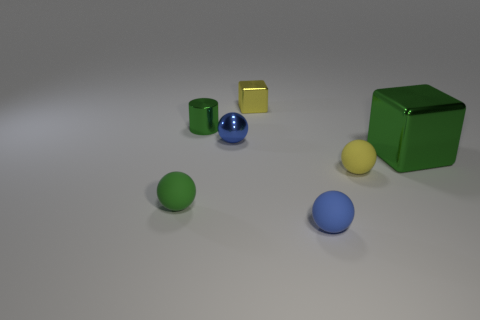How does the lighting affect the appearance of the objects in the image? The lighting in the image appears to be coming from the upper right, casting subtle shadows to the lower left of the objects. It enhances the reflective properties of the metallic objects and gives a soft highlight to the edges of each object. The overall effect creates a sense of depth and dimensionality in the scene. 